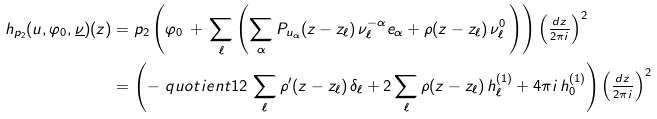Convert formula to latex. <formula><loc_0><loc_0><loc_500><loc_500>h _ { p _ { 2 } } ( u , \varphi _ { 0 } , \underline { \nu } ) ( z ) & = p _ { 2 } \left ( \varphi _ { 0 } \, + \, \sum _ { \ell } \left ( \sum _ { \alpha } P _ { u _ { \alpha } } ( z - z _ { \ell } ) \, \nu _ { \ell } ^ { - \alpha } e _ { \alpha } + \rho ( z - z _ { \ell } ) \, \nu ^ { 0 } _ { \ell } \, \right ) \right ) \left ( \frac { _ { d z } } { ^ { 2 \pi i } } \right ) ^ { 2 } \\ & = \left ( - \ q u o t i e n t { 1 } { 2 } \, \sum _ { \ell } \rho ^ { \prime } ( z - z _ { \ell } ) \, \delta _ { \ell } + 2 \sum _ { \ell } \rho ( z - z _ { \ell } ) \, h ^ { ( 1 ) } _ { \ell } + 4 \pi i \, h ^ { ( 1 ) } _ { 0 } \right ) \left ( \frac { _ { d z } } { ^ { 2 \pi i } } \right ) ^ { 2 }</formula> 